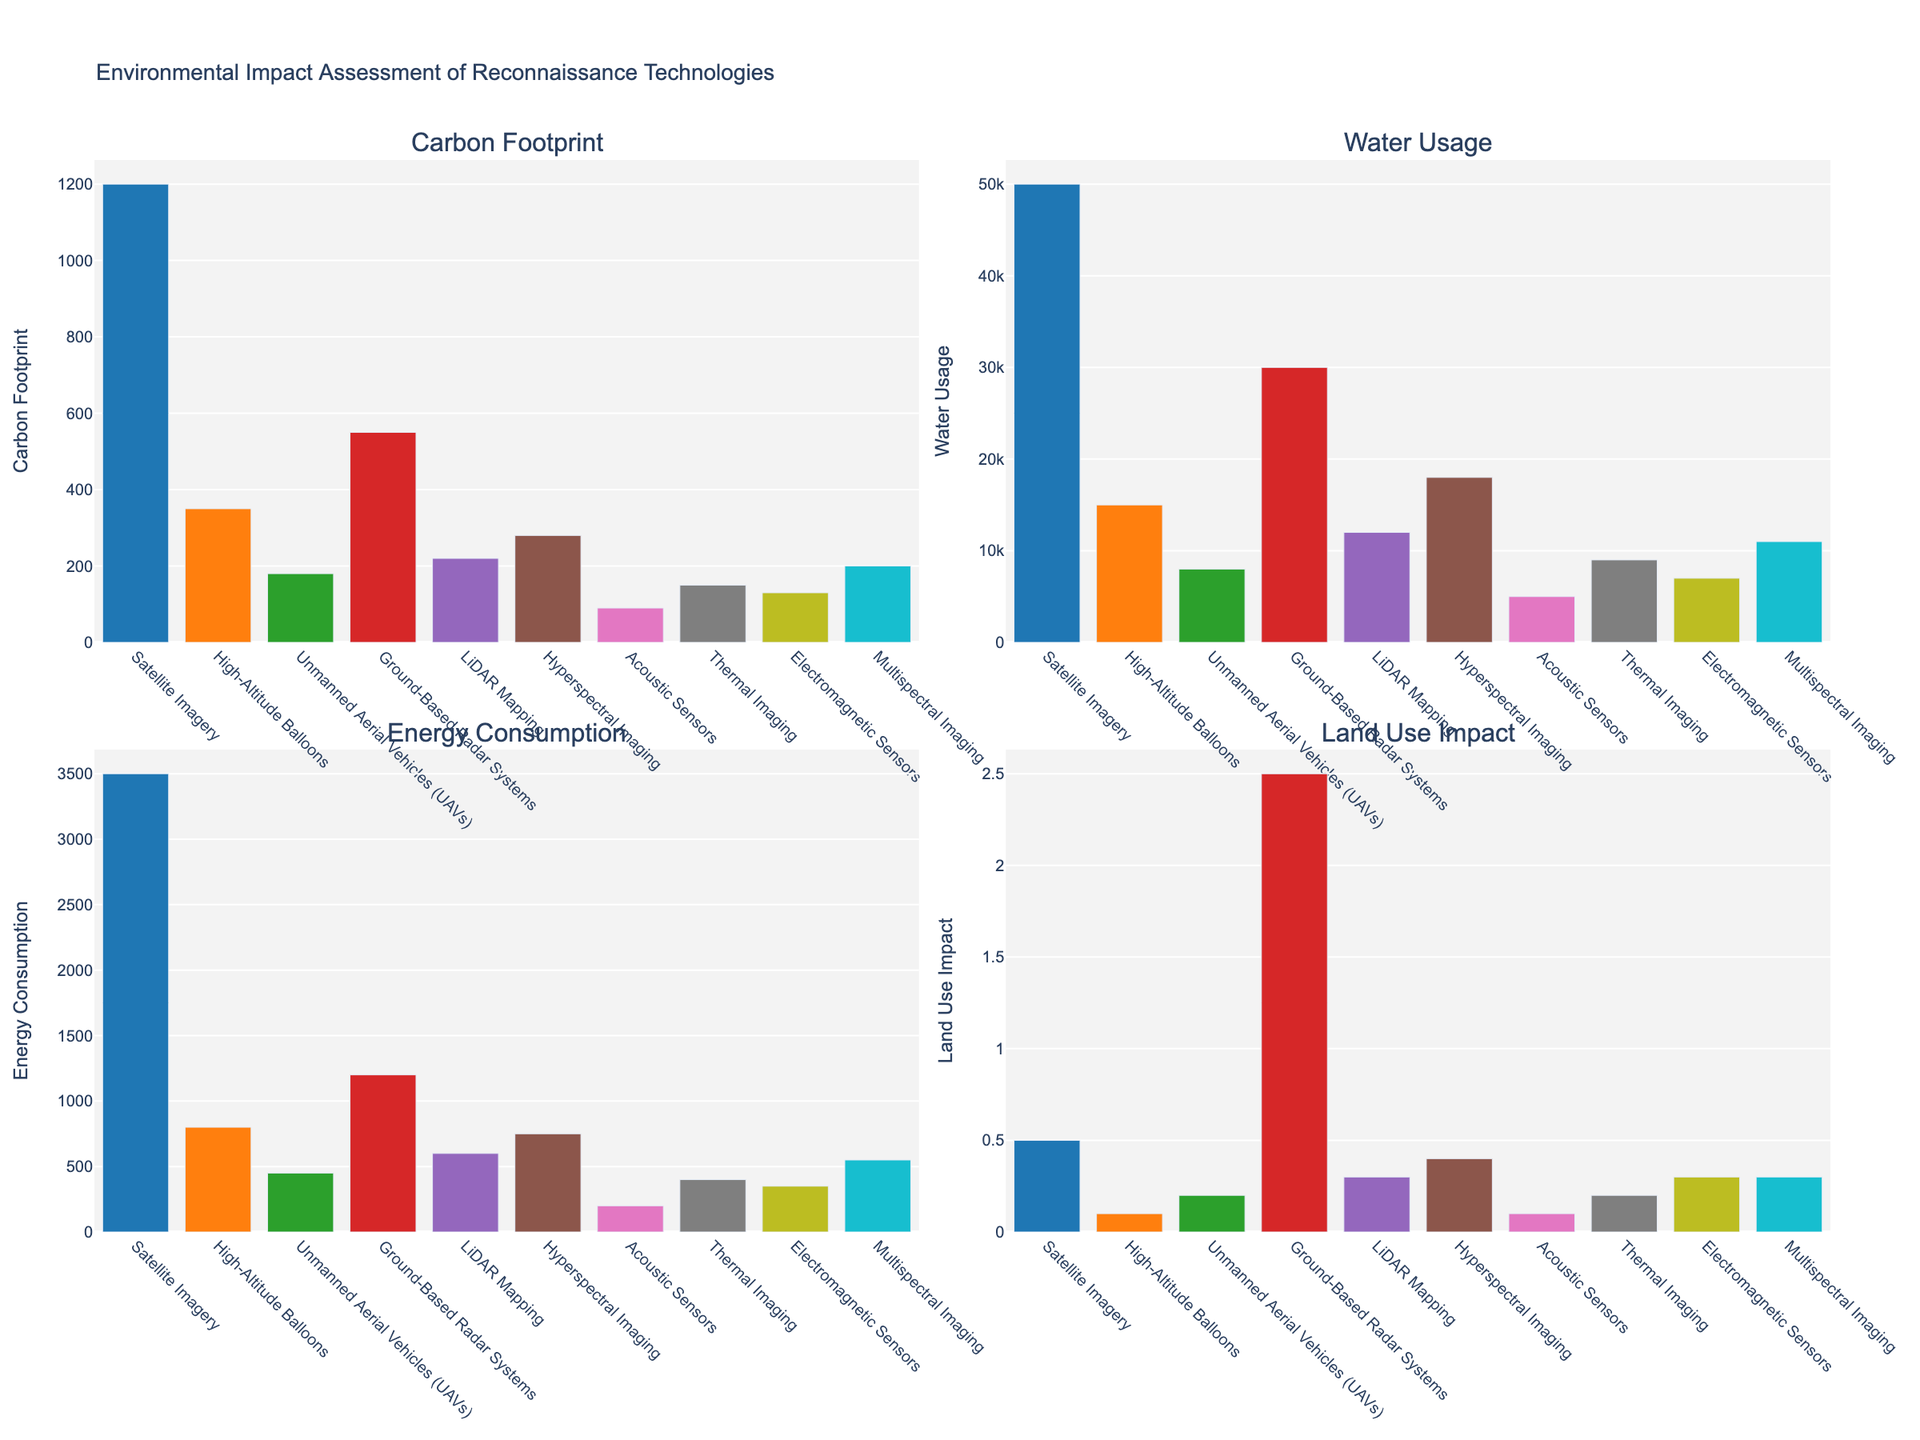Which technology has the highest carbon footprint? By examining the "Carbon Footprint" subplot, the tallest bar represents the technology with the highest carbon footprint. Satellite Imagery has the tallest bar.
Answer: Satellite Imagery How much more water does Ground-Based Radar Systems use compared to UAVs? Refer to the "Water Usage" subplot, identify the water usage of Ground-Based Radar Systems (30,000 gallons/year) and UAVs (8,000 gallons/year). The difference is calculated as 30,000 - 8,000.
Answer: 22,000 gallons/year What is the average energy consumption of LiDAR Mapping and Hyperspectral Imaging? In the "Energy Consumption" subplot, the values for LiDAR Mapping (600 MWh/year) and Hyperspectral Imaging (750 MWh/year) are found. The average is calculated as (600 + 750) / 2.
Answer: 675 MWh/year Which technology has the smallest land use impact? By examining the "Land Use Impact" subplot, the shortest bar represents the technology with the smallest land use impact. Both High-Altitude Balloons and Acoustic Sensors have the shortest bars.
Answer: High-Altitude Balloons/Acoustic Sensors Compare the carbon footprint of Acoustic Sensors to Thermal Imaging. Which one is lower and by how much? In the "Carbon Footprint" subplot, Acoustic Sensors have a footprint of 90 tons CO2e/year and Thermal Imaging has 150 tons CO2e/year. The difference is calculated as 150 - 90.
Answer: Acoustic Sensors by 60 tons CO2e/year How does Multispectral Imaging's water usage compare to the average water usage of Electromagnetic Sensors and Hyperspectral Imaging? Locate the values for Multispectral Imaging (11,000 gallons/year), Electromagnetic Sensors (7,000 gallons/year), and Hyperspectral Imaging (18,000 gallons/year) in the "Water Usage" subplot. The average water usage of the latter two is (7,000 + 18,000) / 2 = 12,500 gallons/year. Compare this to 11,000.
Answer: Multispectral Imaging uses 1,500 gallons/year less Which technology has the closest energy consumption to 500 MWh/year? By observing the "Energy Consumption" subplot, UAVs have one of the closets values to 500 MWh/year, consuming 450 MWh/year.
Answer: UAVs Which technology's land use impact is twice that of Acoustic Sensors? Identify that Acoustic Sensors have a land use impact of 0.1 acres. Double this value is 0.2 acres. In the "Land Use Impact" subplot, UAVs have a land use impact of exactly 0.2 acres.
Answer: UAVs What is the difference in carbon footprint between the highest and the lowest technologies? Refer to the "Carbon Footprint" subplot, the highest is Satellite Imagery (1,200 tons CO2e/year) and the lowest is Acoustic Sensors (90 tons CO2e/year). Calculate the difference as 1,200 - 90.
Answer: 1,110 tons CO2e/year 